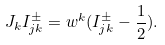Convert formula to latex. <formula><loc_0><loc_0><loc_500><loc_500>J _ { k } I _ { j k } ^ { \pm } = w ^ { k } ( I _ { j k } ^ { \pm } - \frac { 1 } { 2 } ) .</formula> 